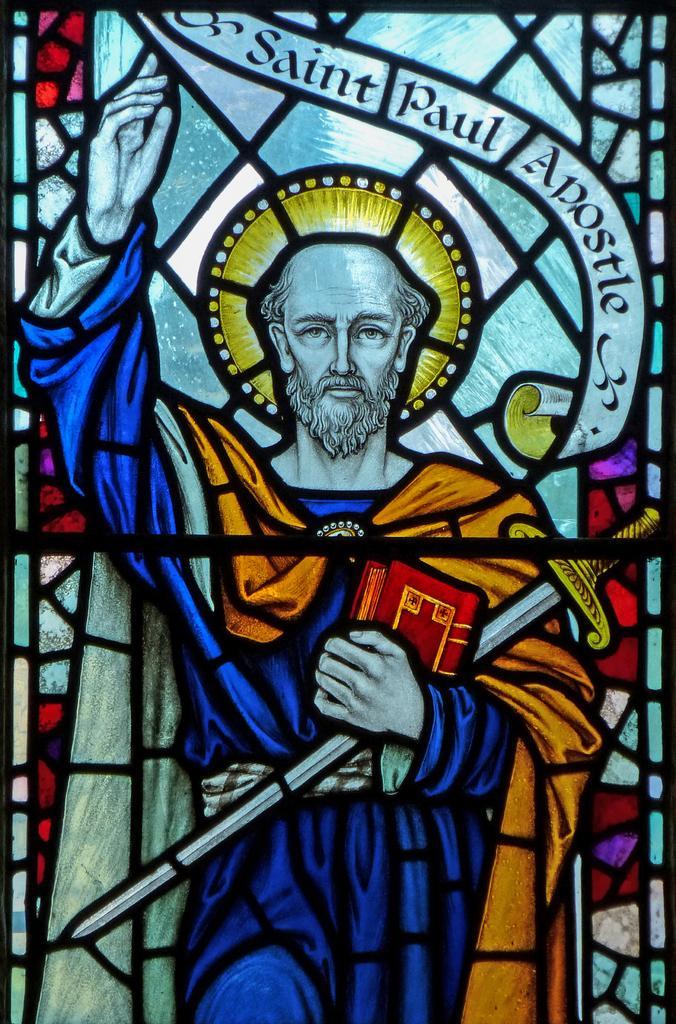How would you summarize this image in a sentence or two? This picture seems to be an edited image. In the center we can see the drawing of a person wearing blue color dress and holding some objects. At the top we can see the text on the image. 